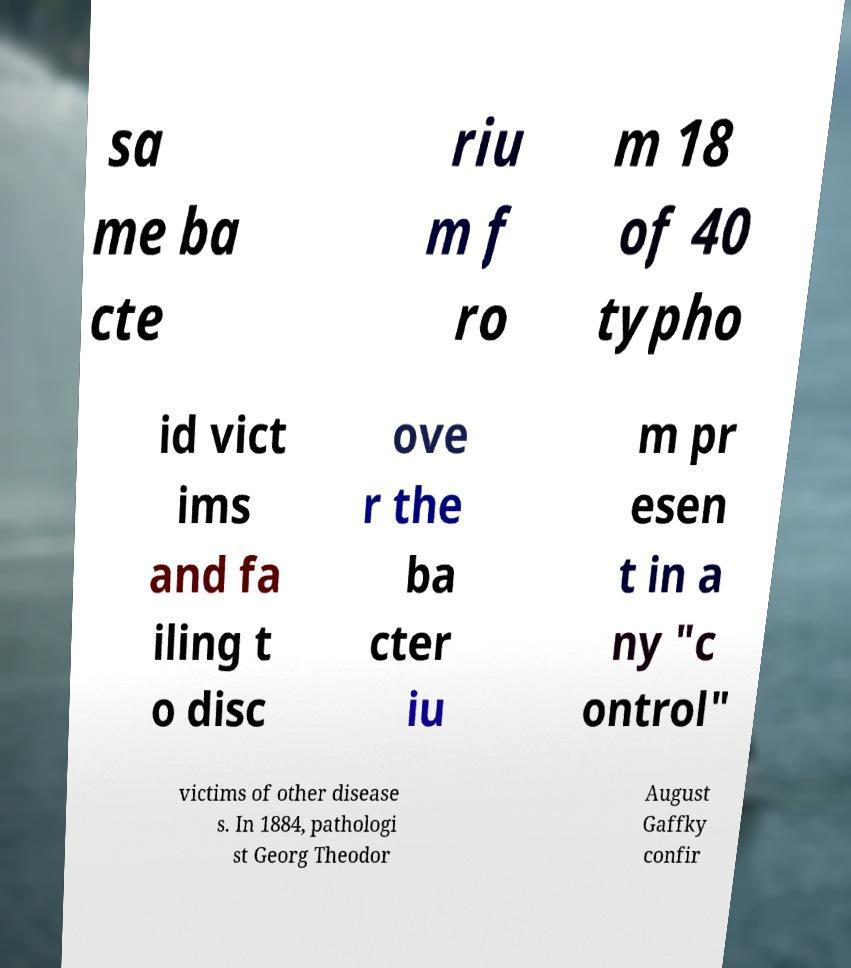Could you assist in decoding the text presented in this image and type it out clearly? sa me ba cte riu m f ro m 18 of 40 typho id vict ims and fa iling t o disc ove r the ba cter iu m pr esen t in a ny "c ontrol" victims of other disease s. In 1884, pathologi st Georg Theodor August Gaffky confir 